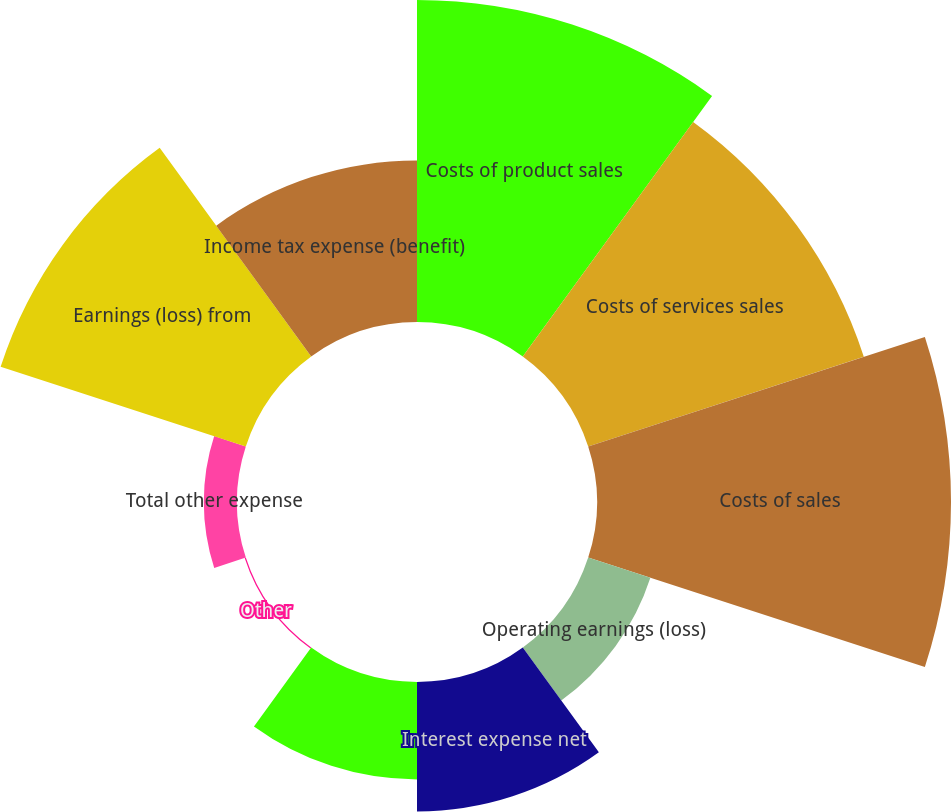Convert chart to OTSL. <chart><loc_0><loc_0><loc_500><loc_500><pie_chart><fcel>Costs of product sales<fcel>Costs of services sales<fcel>Costs of sales<fcel>Operating earnings (loss)<fcel>Interest expense net<fcel>Gains (losses) on sales of<fcel>Other<fcel>Total other expense<fcel>Earnings (loss) from<fcel>Income tax expense (benefit)<nl><fcel>18.81%<fcel>16.93%<fcel>20.68%<fcel>3.82%<fcel>7.56%<fcel>5.69%<fcel>0.07%<fcel>1.94%<fcel>15.06%<fcel>9.44%<nl></chart> 